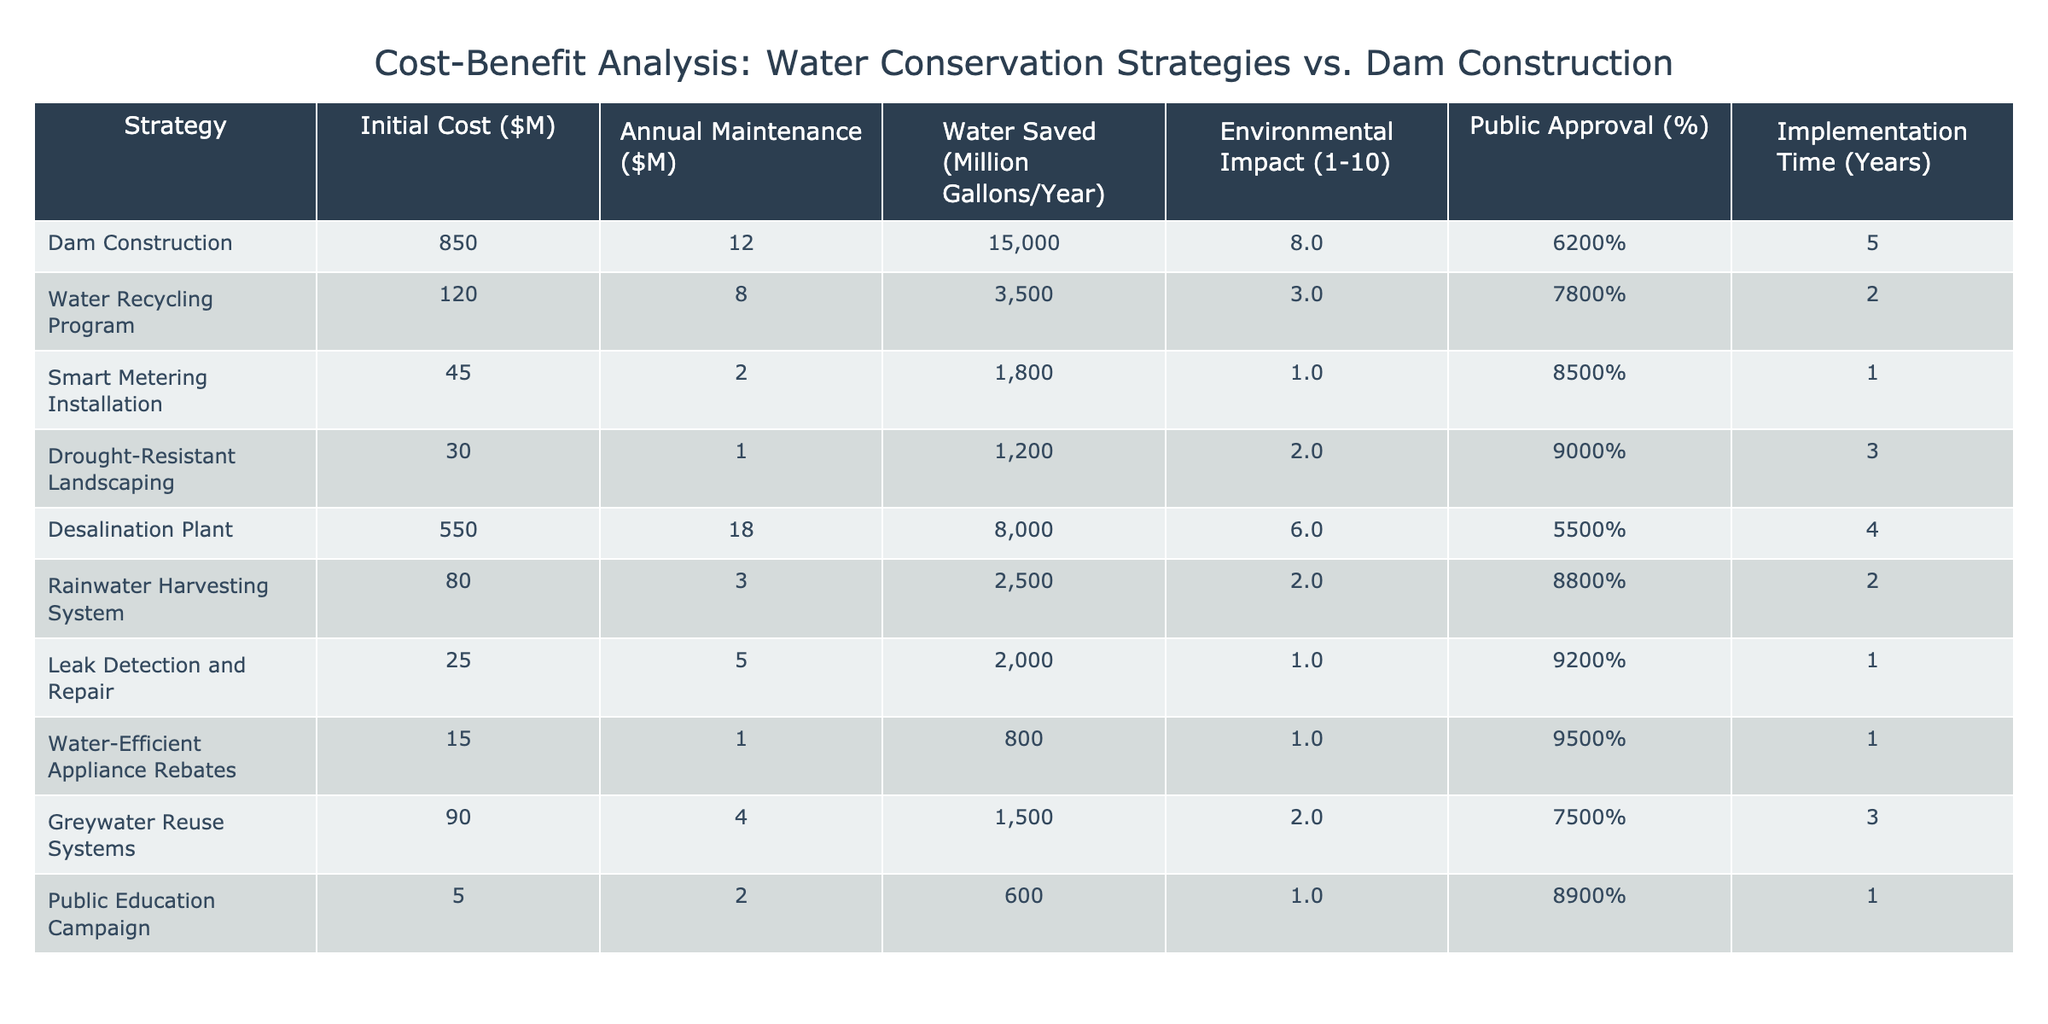What is the initial cost of the dam construction strategy? The initial cost for dam construction is given directly in the table under "Initial Cost," which shows $850 million.
Answer: 850 million Which strategy has the highest public approval? Looking at the "Public Approval" column, the strategy with the highest public approval percentage is "Water-Efficient Appliance Rebates" at 95%.
Answer: 95% What is the annual maintenance cost of the water recycling program? The annual maintenance cost is listed in the "Annual Maintenance" column for the water recycling program, which is $8 million.
Answer: 8 million What is the environmental impact score of the desalination plant? The environmental impact score for the desalination plant is found in the "Environmental Impact" column, where it is rated 6 out of 10.
Answer: 6 Calculate the total water saved per year from both the dam construction and desalination plant. The water saved for dam construction is 15,000 million gallons and for the desalination plant is 8,000 million gallons. Adding these together gives 15,000 + 8,000 = 23,000 million gallons.
Answer: 23,000 million gallons Which water conservation strategy has the shortest implementation time? By examining the "Implementation Time" column, the strategy with the shortest implementation time of 1 year is "Smart Metering Installation," "Leak Detection and Repair," and "Water-Efficient Appliance Rebates."
Answer: 1 year Is the annual maintenance cost of the drought-resistant landscaping less than the water recycling program? The annual maintenance cost of drought-resistant landscaping is $1 million, while that of the water recycling program is $8 million. Since $1 million is less than $8 million, the statement is true.
Answer: Yes What is the average public approval percentage across all strategies? To find the average public approval, we sum the percentages: 62 + 78 + 85 + 90 + 55 + 88 + 92 + 95 + 75 + 89 = 855. There are 10 strategies, so the average is 855 / 10 = 85.5.
Answer: 85.5 If we compare the water saved per million dollars spent, which strategy offers the best efficiency? First, we calculate the water saved per million dollars for each strategy: For the dam, it's 15000/850 = 17.65; Water Recycling is 3500/120 = 29.17; Smart Metering is 1800/45 = 40.00; Drought Landscaping is 1200/30 = 40.00; Desalination is 8000/550 = 14.55; Rainwater is 2500/80 = 31.25; Leak Detection is 2000/25 = 80.00; Appliance Rebates is 800/15 = 53.33; Greywater Systems is 1500/90 = 16.67; Public Education is 600/5 = 120.00. The highest value is for the Public Education Campaign.
Answer: Public Education Campaign What is the difference in environmental impact between the dam construction and the leak detection and repair strategy? The environmental impact of the dam construction is 8, and for the leak detection strategy, it is 1. The difference is calculated as 8 - 1 = 7.
Answer: 7 